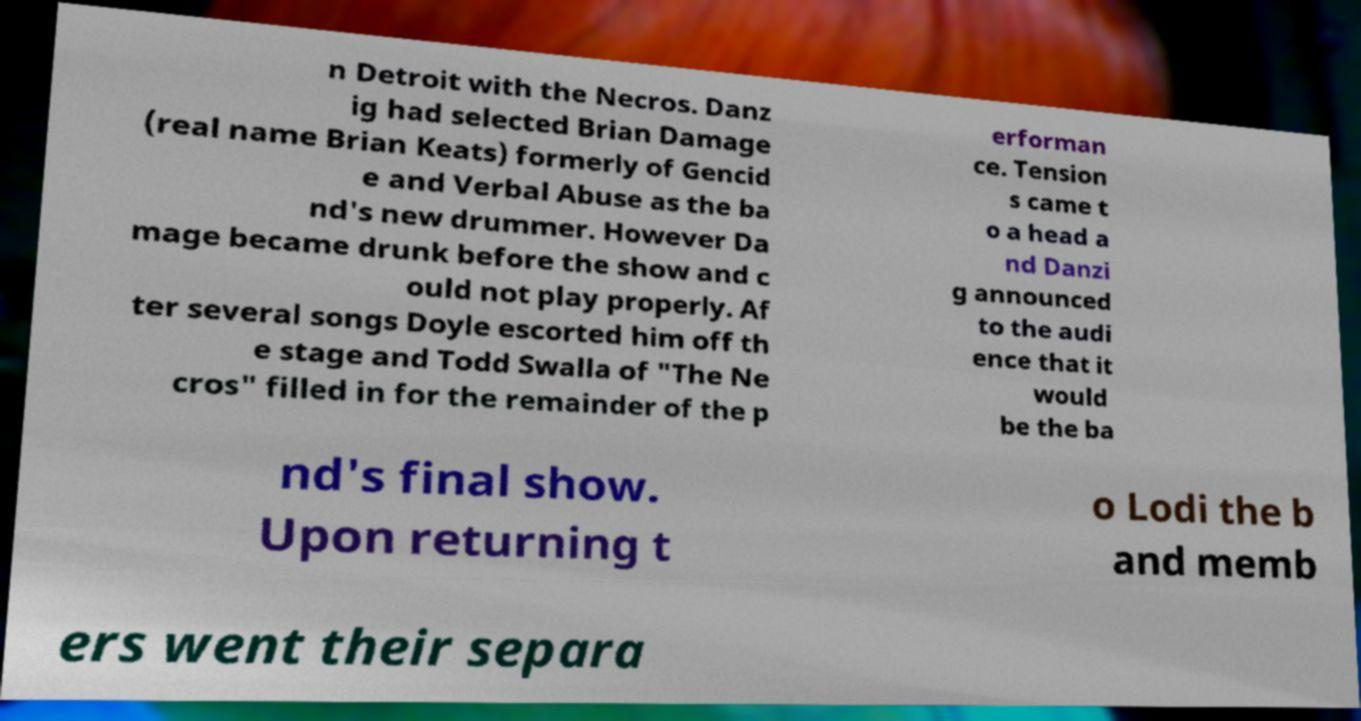Please read and relay the text visible in this image. What does it say? n Detroit with the Necros. Danz ig had selected Brian Damage (real name Brian Keats) formerly of Gencid e and Verbal Abuse as the ba nd's new drummer. However Da mage became drunk before the show and c ould not play properly. Af ter several songs Doyle escorted him off th e stage and Todd Swalla of "The Ne cros" filled in for the remainder of the p erforman ce. Tension s came t o a head a nd Danzi g announced to the audi ence that it would be the ba nd's final show. Upon returning t o Lodi the b and memb ers went their separa 